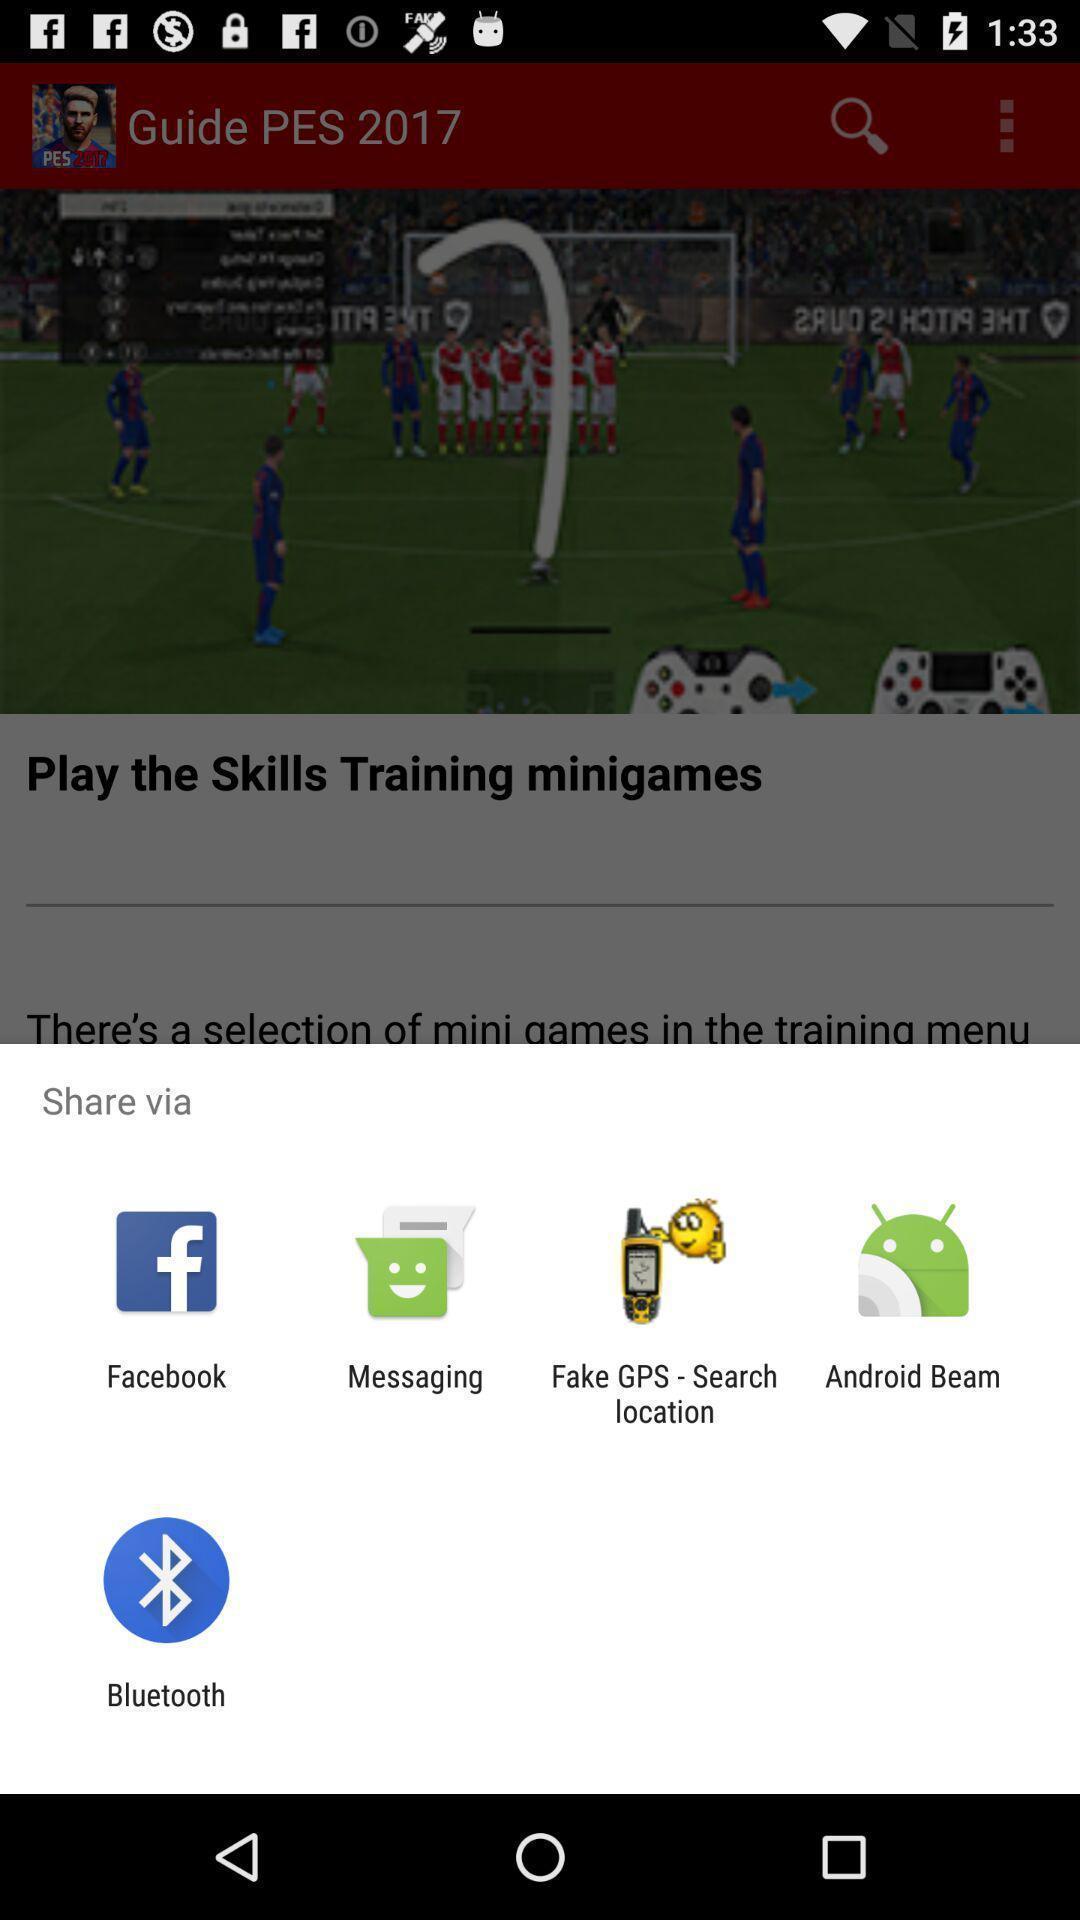Provide a description of this screenshot. Push up showing for social apps. 